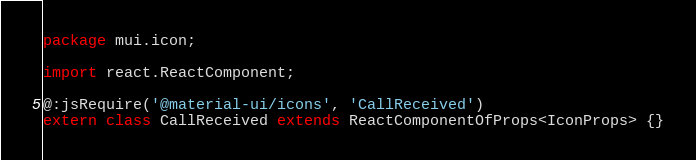<code> <loc_0><loc_0><loc_500><loc_500><_Haxe_>package mui.icon;

import react.ReactComponent;

@:jsRequire('@material-ui/icons', 'CallReceived')
extern class CallReceived extends ReactComponentOfProps<IconProps> {}
</code> 